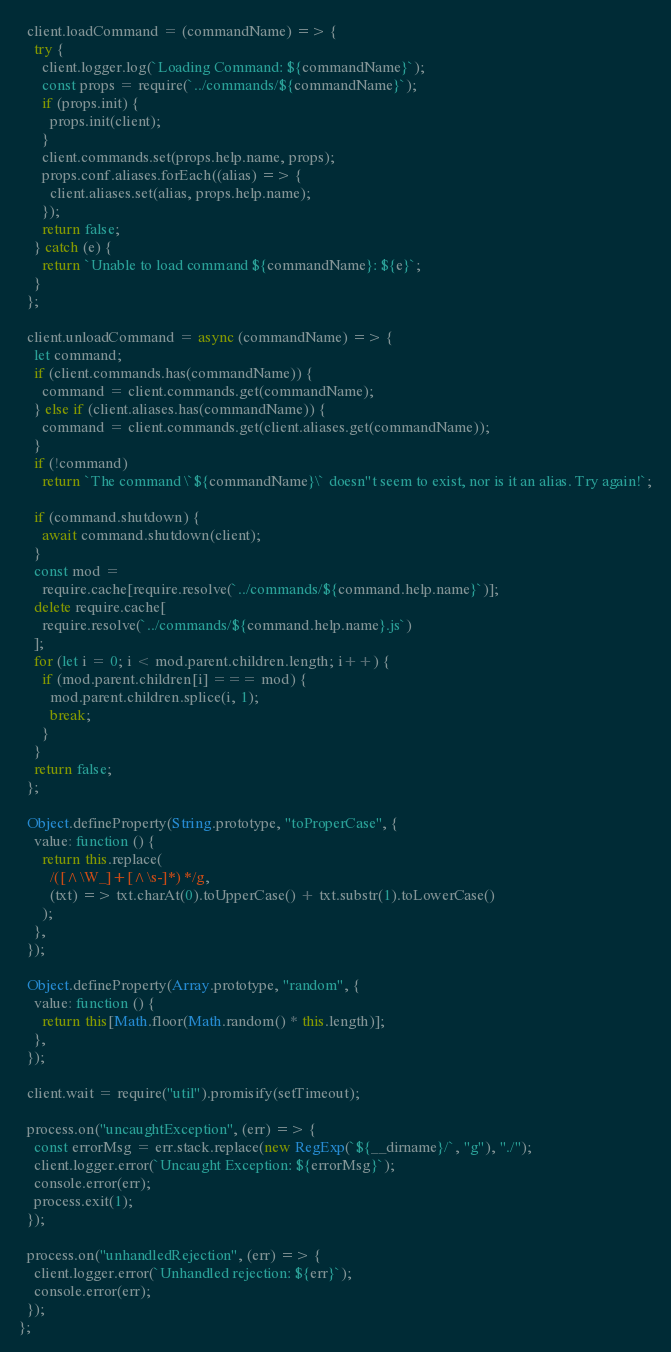Convert code to text. <code><loc_0><loc_0><loc_500><loc_500><_JavaScript_>  client.loadCommand = (commandName) => {
    try {
      client.logger.log(`Loading Command: ${commandName}`);
      const props = require(`../commands/${commandName}`);
      if (props.init) {
        props.init(client);
      }
      client.commands.set(props.help.name, props);
      props.conf.aliases.forEach((alias) => {
        client.aliases.set(alias, props.help.name);
      });
      return false;
    } catch (e) {
      return `Unable to load command ${commandName}: ${e}`;
    }
  };

  client.unloadCommand = async (commandName) => {
    let command;
    if (client.commands.has(commandName)) {
      command = client.commands.get(commandName);
    } else if (client.aliases.has(commandName)) {
      command = client.commands.get(client.aliases.get(commandName));
    }
    if (!command)
      return `The command \`${commandName}\` doesn"t seem to exist, nor is it an alias. Try again!`;

    if (command.shutdown) {
      await command.shutdown(client);
    }
    const mod =
      require.cache[require.resolve(`../commands/${command.help.name}`)];
    delete require.cache[
      require.resolve(`../commands/${command.help.name}.js`)
    ];
    for (let i = 0; i < mod.parent.children.length; i++) {
      if (mod.parent.children[i] === mod) {
        mod.parent.children.splice(i, 1);
        break;
      }
    }
    return false;
  };

  Object.defineProperty(String.prototype, "toProperCase", {
    value: function () {
      return this.replace(
        /([^\W_]+[^\s-]*) */g,
        (txt) => txt.charAt(0).toUpperCase() + txt.substr(1).toLowerCase()
      );
    },
  });

  Object.defineProperty(Array.prototype, "random", {
    value: function () {
      return this[Math.floor(Math.random() * this.length)];
    },
  });

  client.wait = require("util").promisify(setTimeout);

  process.on("uncaughtException", (err) => {
    const errorMsg = err.stack.replace(new RegExp(`${__dirname}/`, "g"), "./");
    client.logger.error(`Uncaught Exception: ${errorMsg}`);
    console.error(err);
    process.exit(1);
  });

  process.on("unhandledRejection", (err) => {
    client.logger.error(`Unhandled rejection: ${err}`);
    console.error(err);
  });
};
</code> 